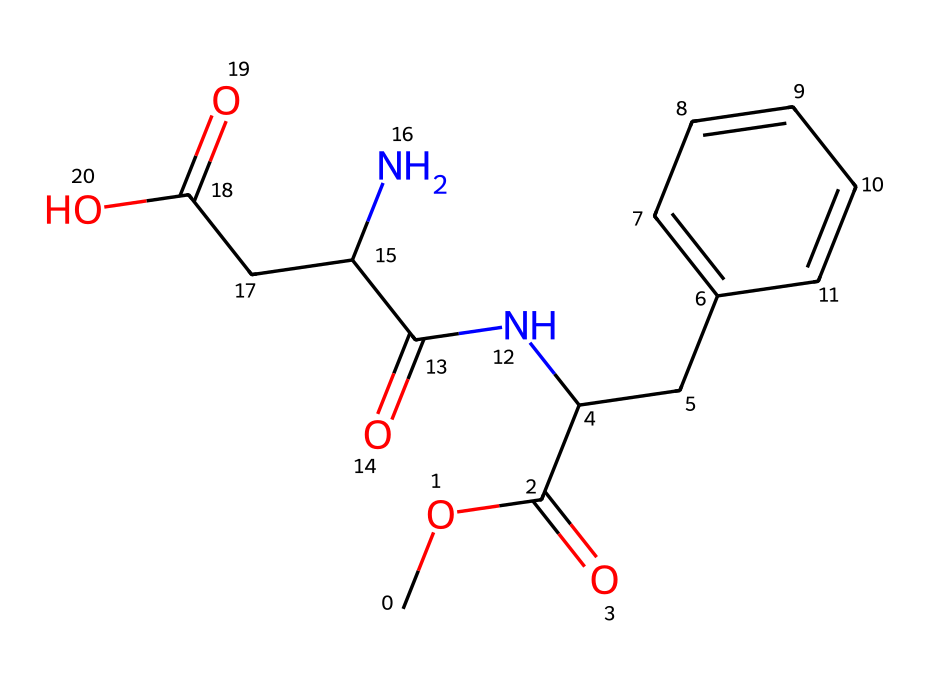What is the molecular formula of aspartame based on the SMILES representation? Analyzing the SMILES string, we can identify the presence of carbon (C), hydrogen (H), nitrogen (N), and oxygen (O) atoms. Counting each type of atom gives us a molecular formula of C14H18N2O5.
Answer: C14H18N2O5 How many rings are present in the structure of aspartame? By examining the chemical structure reflected in the SMILES representation, we see a phenyl ring (the benzene part), which indicates a single cyclic structure.
Answer: 1 What functional groups are found in aspartame? The SMILES representation indicates the presence of an ester (from the COC(=O) part), an amide (from the NC(=O) part), and carboxylic acids (CC(=O)O). Therefore, multiple functional groups are identified.
Answer: ester, amide, carboxylic acids Which part of the molecule is responsible for its sweetness? The nitrogen-containing groups (specifically the amide linkages) along with the phenyl ring contribute to the sweet taste associated with aspartame. The spatial arrangement and interactions with taste receptors play a significant role.
Answer: nitrogen-containing groups What is the total number of oxygen atoms in aspartame? By reviewing the SMILES structure, we can count the modifications and portions indicating the presence of oxygen. There are five distinct oxygen atoms identified in the molecule.
Answer: 5 In what pH range is aspartame stable? Aspartame is typically stable within a neutral pH range (approximately pH 6 to 7), and its degradation into aspartic acid and phenylalanine occurs at extreme pH levels.
Answer: pH 6 to 7 What is the significance of the aromatic ring in aspartame's structure? The presence of the aromatic ring enhances the flavor profile and contributes to the overall sweetness perception, while also providing stability to the compound through its resonance structures.
Answer: enhances flavor profile 